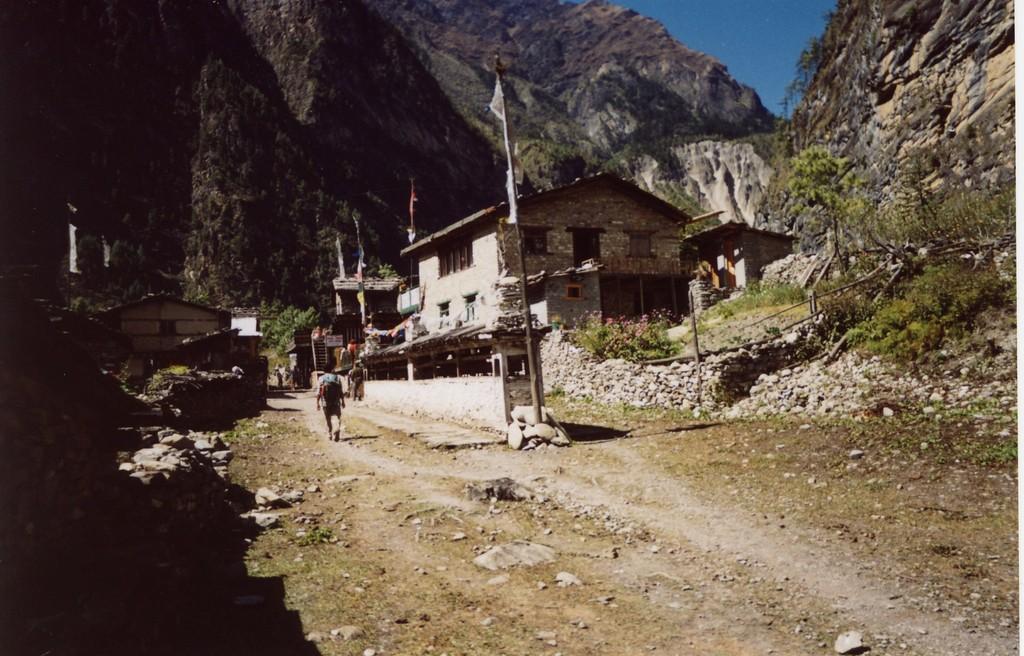How would you summarize this image in a sentence or two? In this image I can see the person walking and I can see few houses, trees in green color, few flags attached to the poles. In the background I can see few rocks and the sky is in blue color. 